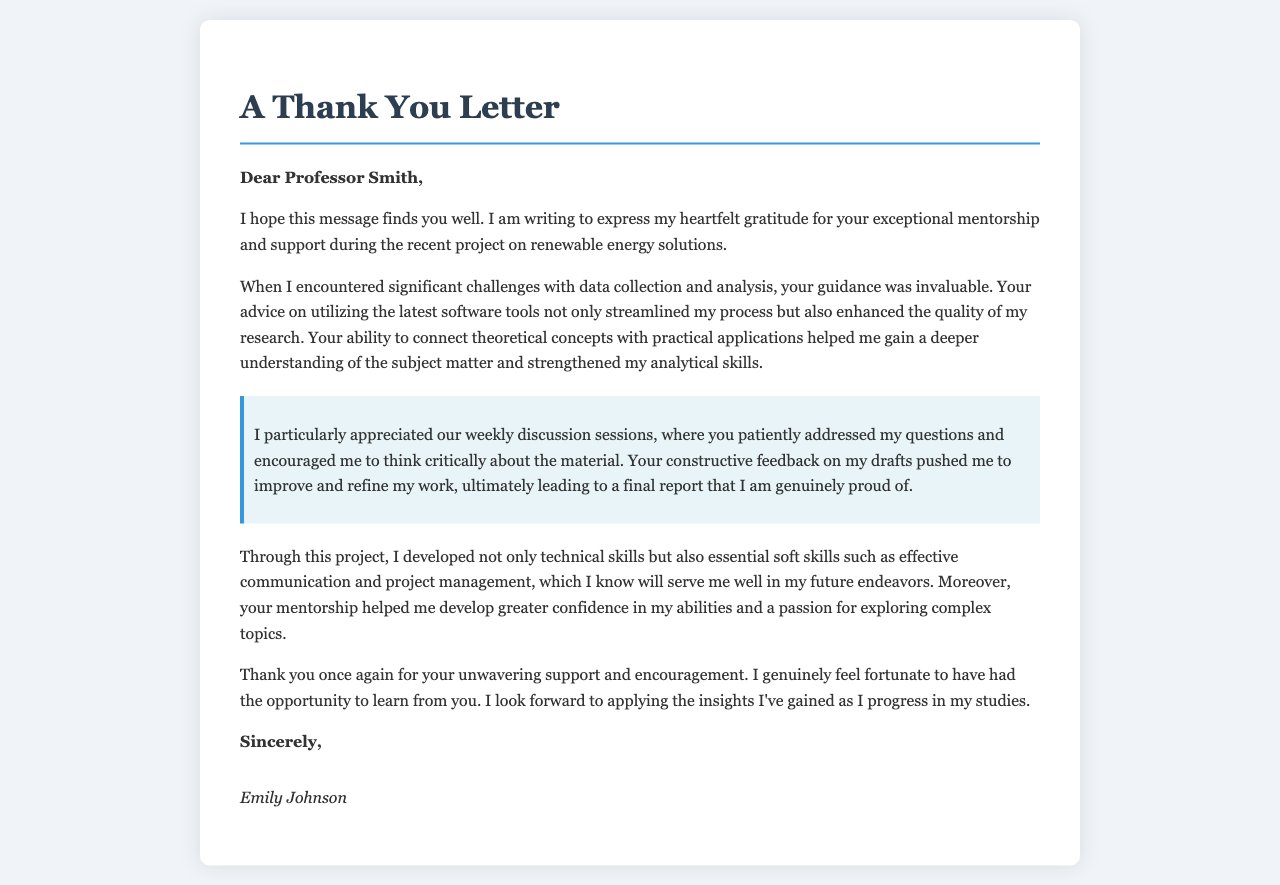what is the name of the professor mentioned in the letter? The letter addresses Professor Smith directly, indicating their name as the recipient.
Answer: Professor Smith who is the person writing the letter? The signature at the end of the letter shows who the author is.
Answer: Emily Johnson what was the main topic of the project discussed in the letter? The letter specifies that the project focused on renewable energy solutions.
Answer: renewable energy solutions how did the author feel about the mentorship received? The author expresses heartfelt gratitude, indicating a positive emotional response to the mentorship.
Answer: grateful what skills did the author develop through the project? The letter lists technical skills and essential soft skills that were gained, emphasizing personal growth.
Answer: technical and soft skills how often did the author meet with the professor for discussions? The author mentions weekly discussions, indicating the frequency of their meetings.
Answer: weekly what did the author appreciate about the professor's feedback? The author notes that the feedback was constructive, which contributed to improving their work.
Answer: constructive feedback what feeling did the author develop towards complex topics? The author mentions developing a passion for exploring complex topics due to the mentorship.
Answer: passion 